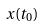Convert formula to latex. <formula><loc_0><loc_0><loc_500><loc_500>x ( t _ { 0 } )</formula> 